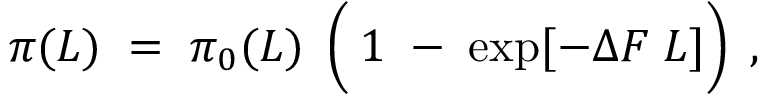<formula> <loc_0><loc_0><loc_500><loc_500>\pi ( L ) \, = \, \pi _ { 0 } ( L ) \, \left ( { } 1 \, - \, \exp [ - \Delta F \, L ] \right ) \, ,</formula> 